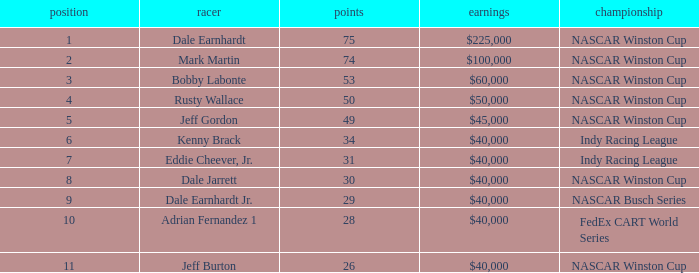How much did Jeff Burton win? $40,000. 